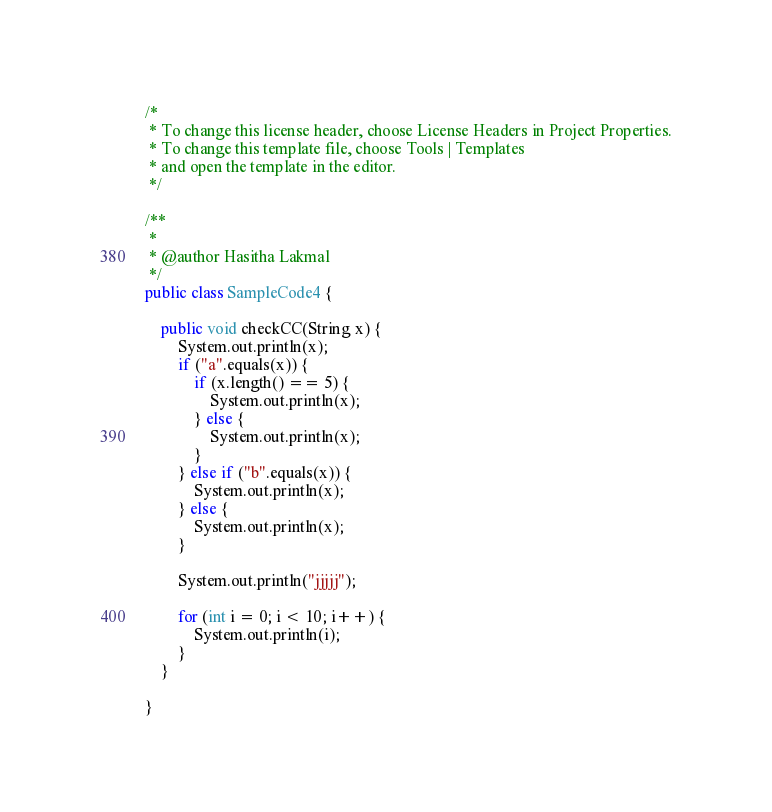<code> <loc_0><loc_0><loc_500><loc_500><_Java_>/*
 * To change this license header, choose License Headers in Project Properties.
 * To change this template file, choose Tools | Templates
 * and open the template in the editor.
 */

/**
 *
 * @author Hasitha Lakmal
 */
public class SampleCode4 {

    public void checkCC(String x) {
        System.out.println(x);
        if ("a".equals(x)) {
            if (x.length() == 5) {
                System.out.println(x);
            } else {
                System.out.println(x);
            }
        } else if ("b".equals(x)) {
            System.out.println(x);
        } else {
            System.out.println(x);
        }
        
        System.out.println("jjjjj");
        
        for (int i = 0; i < 10; i++) {
            System.out.println(i);
        }
    }

}
</code> 